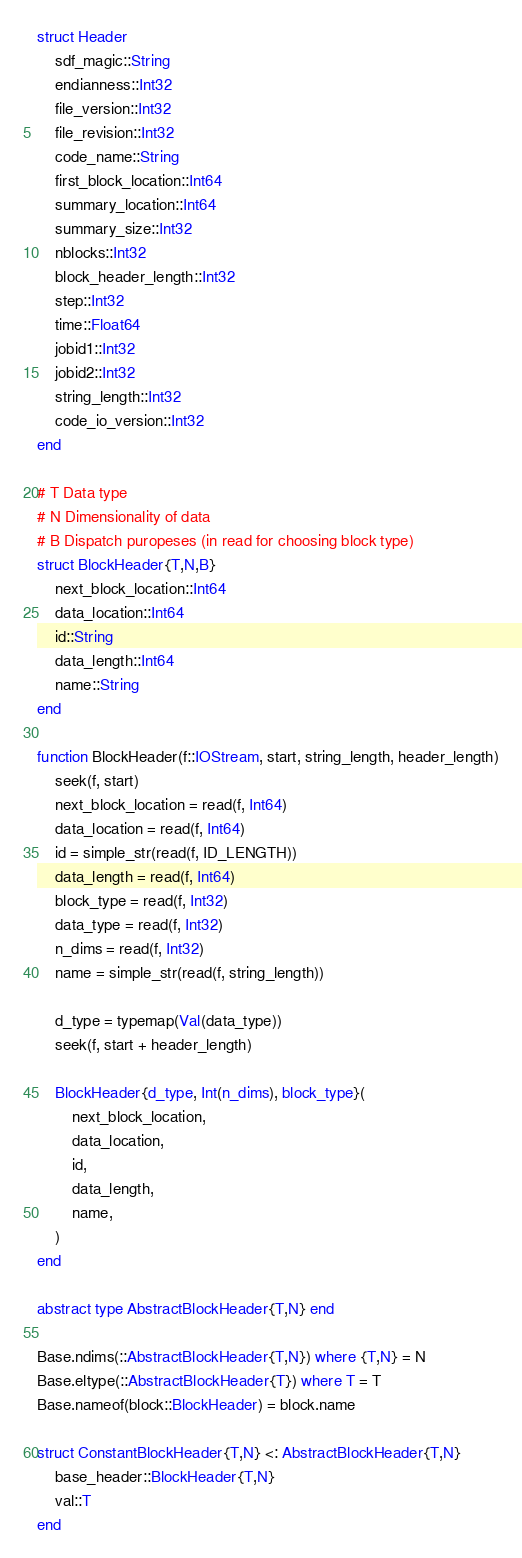Convert code to text. <code><loc_0><loc_0><loc_500><loc_500><_Julia_>struct Header
    sdf_magic::String
    endianness::Int32
    file_version::Int32
    file_revision::Int32
    code_name::String
    first_block_location::Int64
    summary_location::Int64
    summary_size::Int32
    nblocks::Int32
    block_header_length::Int32
    step::Int32
    time::Float64
    jobid1::Int32
    jobid2::Int32
    string_length::Int32
    code_io_version::Int32
end

# T Data type
# N Dimensionality of data
# B Dispatch puropeses (in read for choosing block type)
struct BlockHeader{T,N,B}
    next_block_location::Int64
    data_location::Int64
    id::String
    data_length::Int64
    name::String
end

function BlockHeader(f::IOStream, start, string_length, header_length)
    seek(f, start)
    next_block_location = read(f, Int64)
    data_location = read(f, Int64)
    id = simple_str(read(f, ID_LENGTH))
    data_length = read(f, Int64)
    block_type = read(f, Int32)
    data_type = read(f, Int32)
    n_dims = read(f, Int32)
    name = simple_str(read(f, string_length))

    d_type = typemap(Val(data_type))
    seek(f, start + header_length)

    BlockHeader{d_type, Int(n_dims), block_type}(
        next_block_location,
        data_location,
        id,
        data_length,
        name,
    )
end

abstract type AbstractBlockHeader{T,N} end

Base.ndims(::AbstractBlockHeader{T,N}) where {T,N} = N
Base.eltype(::AbstractBlockHeader{T}) where T = T
Base.nameof(block::BlockHeader) = block.name

struct ConstantBlockHeader{T,N} <: AbstractBlockHeader{T,N}
    base_header::BlockHeader{T,N}
    val::T
end
</code> 